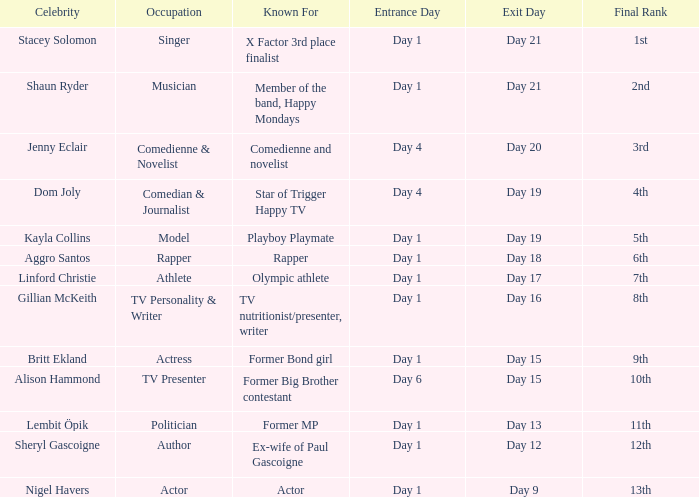What celebrity is famous for being an actor? Nigel Havers. 